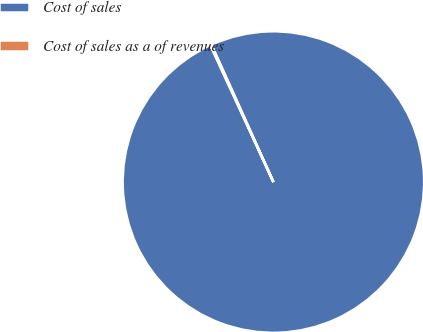<chart> <loc_0><loc_0><loc_500><loc_500><pie_chart><fcel>Cost of sales<fcel>Cost of sales as a of revenues<nl><fcel>99.88%<fcel>0.12%<nl></chart> 